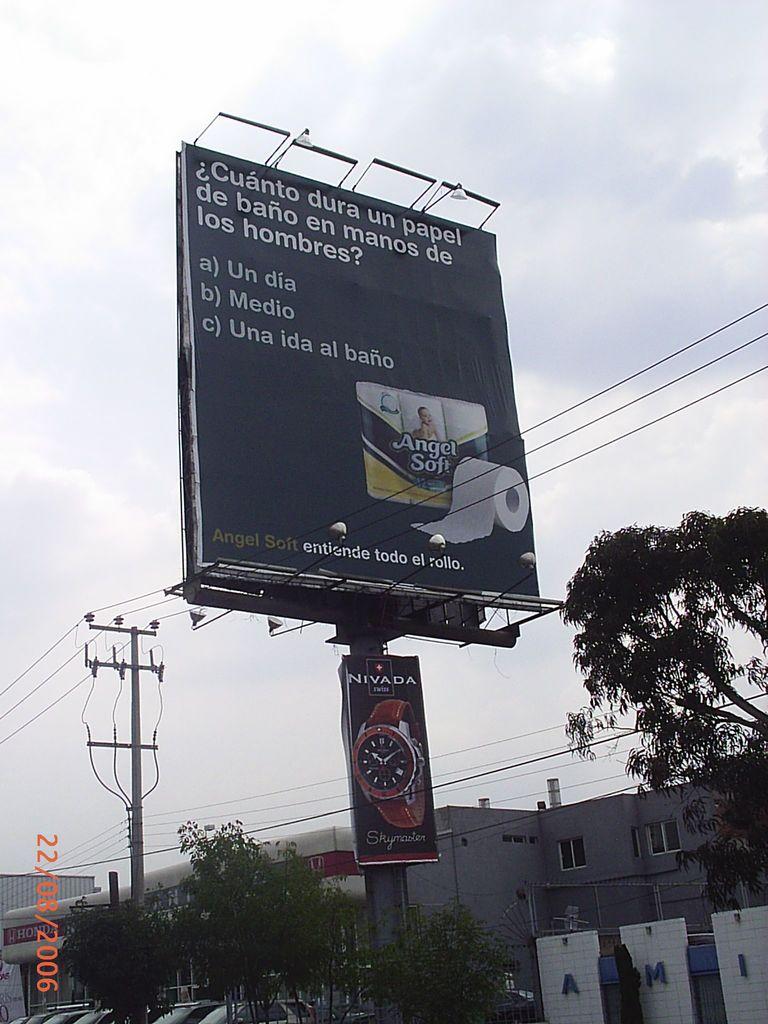What brand of watch is being advertised?
Your response must be concise. Nivada. 